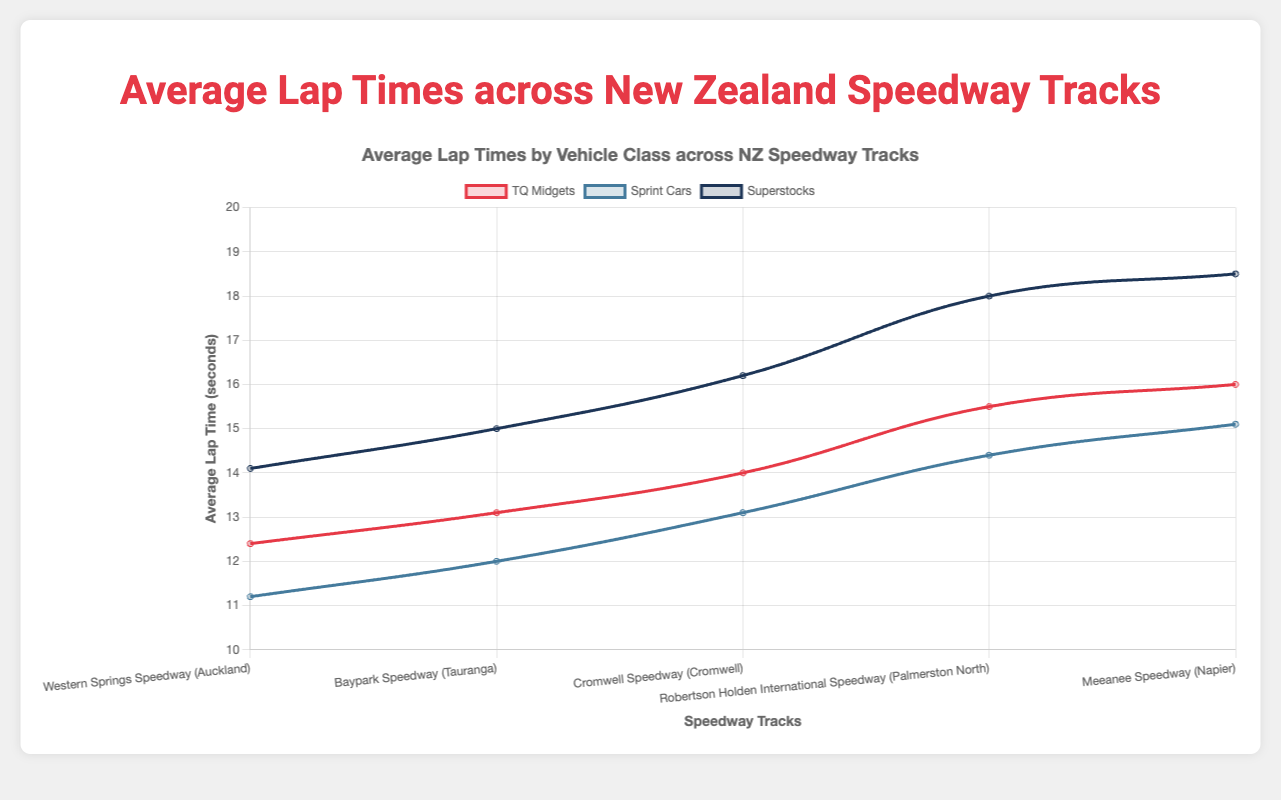Which class of cars has the lowest average lap time at Western Springs Speedway? The average lap times at Western Springs Speedway for each class are: TQ Midgets (12.4), Sprint Cars (11.2), and Superstocks (14.1). Comparing these values shows Sprint Cars have the lowest average lap time.
Answer: Sprint Cars How does the average lap time of Sprint Cars at Baypark Speedway compare to that at Cromwell Speedway? The average lap time of Sprint Cars at Baypark Speedway is 12.0 seconds, whereas at Cromwell Speedway, it is 13.1 seconds. Thus, Sprint Cars are faster on average at Baypark Speedway.
Answer: Baypark Speedway Between TQ Midgets at Meeanee Speedway and Superstocks at Robertson Holden International Speedway, which class has a higher average lap time? The average lap time for TQ Midgets at Meeanee Speedway is 16.0 seconds, while for Superstocks at Robertson Holden International Speedway, it is 18.0 seconds. Therefore, Superstocks have a higher average lap time.
Answer: Superstocks What is the difference in average lap time between TQ Midgets and Superstocks at Cromwell Speedway? The average lap time for TQ Midgets at Cromwell Speedway is 14.0 seconds, and for Superstocks, it is 16.2 seconds. The difference between them is 16.2 - 14.0 = 2.2 seconds.
Answer: 2.2 seconds What's the difference between the highest and lowest average lap times for Sprint Cars across all tracks? The highest average lap time for Sprint Cars is 15.1 seconds at Meeanee Speedway, and the lowest is 11.1 seconds at Western Springs Speedway. The difference is 15.1 - 11.1 = 4 seconds.
Answer: 4 seconds Identify the class and track with the highest average lap time. Among all classes and tracks, the highest average lap time is for Superstocks at Meeanee Speedway, with a time of 18.5 seconds.
Answer: Superstocks at Meeanee Speedway Is there any track where Sprint Cars have a higher average lap time than TQ Midgets? At all tracks, Sprint Cars consistently have lower average lap times than TQ Midgets. For instance, at Western Springs Speedway, the times are 11.2 for Sprint Cars and 12.4 for TQ Midgets.
Answer: No 